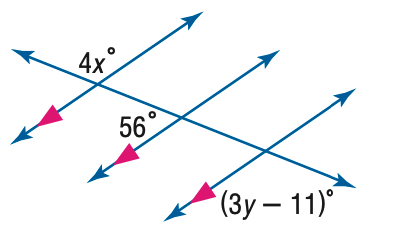Answer the mathemtical geometry problem and directly provide the correct option letter.
Question: Find y in the figure.
Choices: A: 31 B: 45 C: 56 D: 75 B 